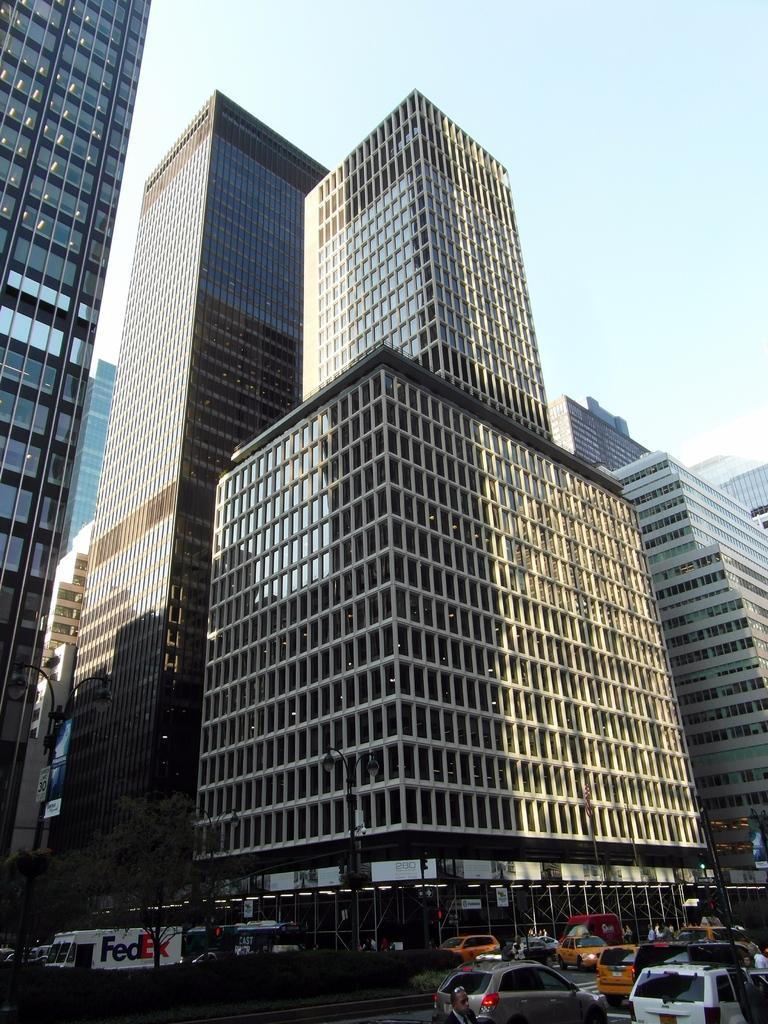Could you give a brief overview of what you see in this image? There are some vehicles on the road at the bottom of this image. There are some trees at the bottom left side of this image. There are some buildings in the background. There is a sky at the top of this image. 